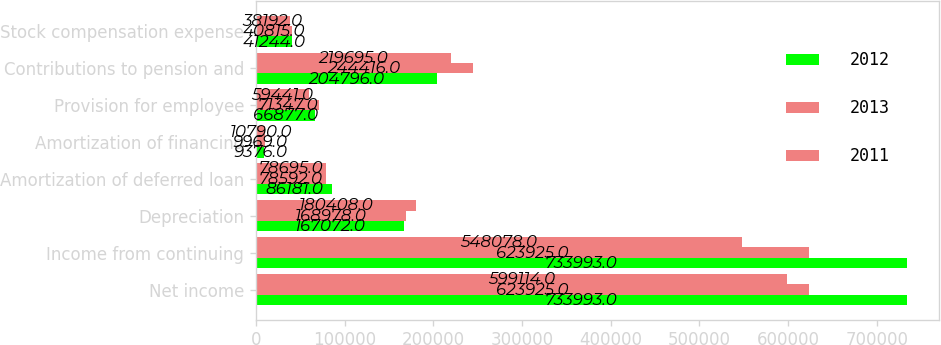Convert chart to OTSL. <chart><loc_0><loc_0><loc_500><loc_500><stacked_bar_chart><ecel><fcel>Net income<fcel>Income from continuing<fcel>Depreciation<fcel>Amortization of deferred loan<fcel>Amortization of financing<fcel>Provision for employee<fcel>Contributions to pension and<fcel>Stock compensation expense<nl><fcel>2012<fcel>733993<fcel>733993<fcel>167072<fcel>86181<fcel>9376<fcel>66877<fcel>204796<fcel>41244<nl><fcel>2013<fcel>623925<fcel>623925<fcel>168978<fcel>78592<fcel>9969<fcel>71347<fcel>244416<fcel>40815<nl><fcel>2011<fcel>599114<fcel>548078<fcel>180408<fcel>78695<fcel>10790<fcel>59441<fcel>219695<fcel>38192<nl></chart> 